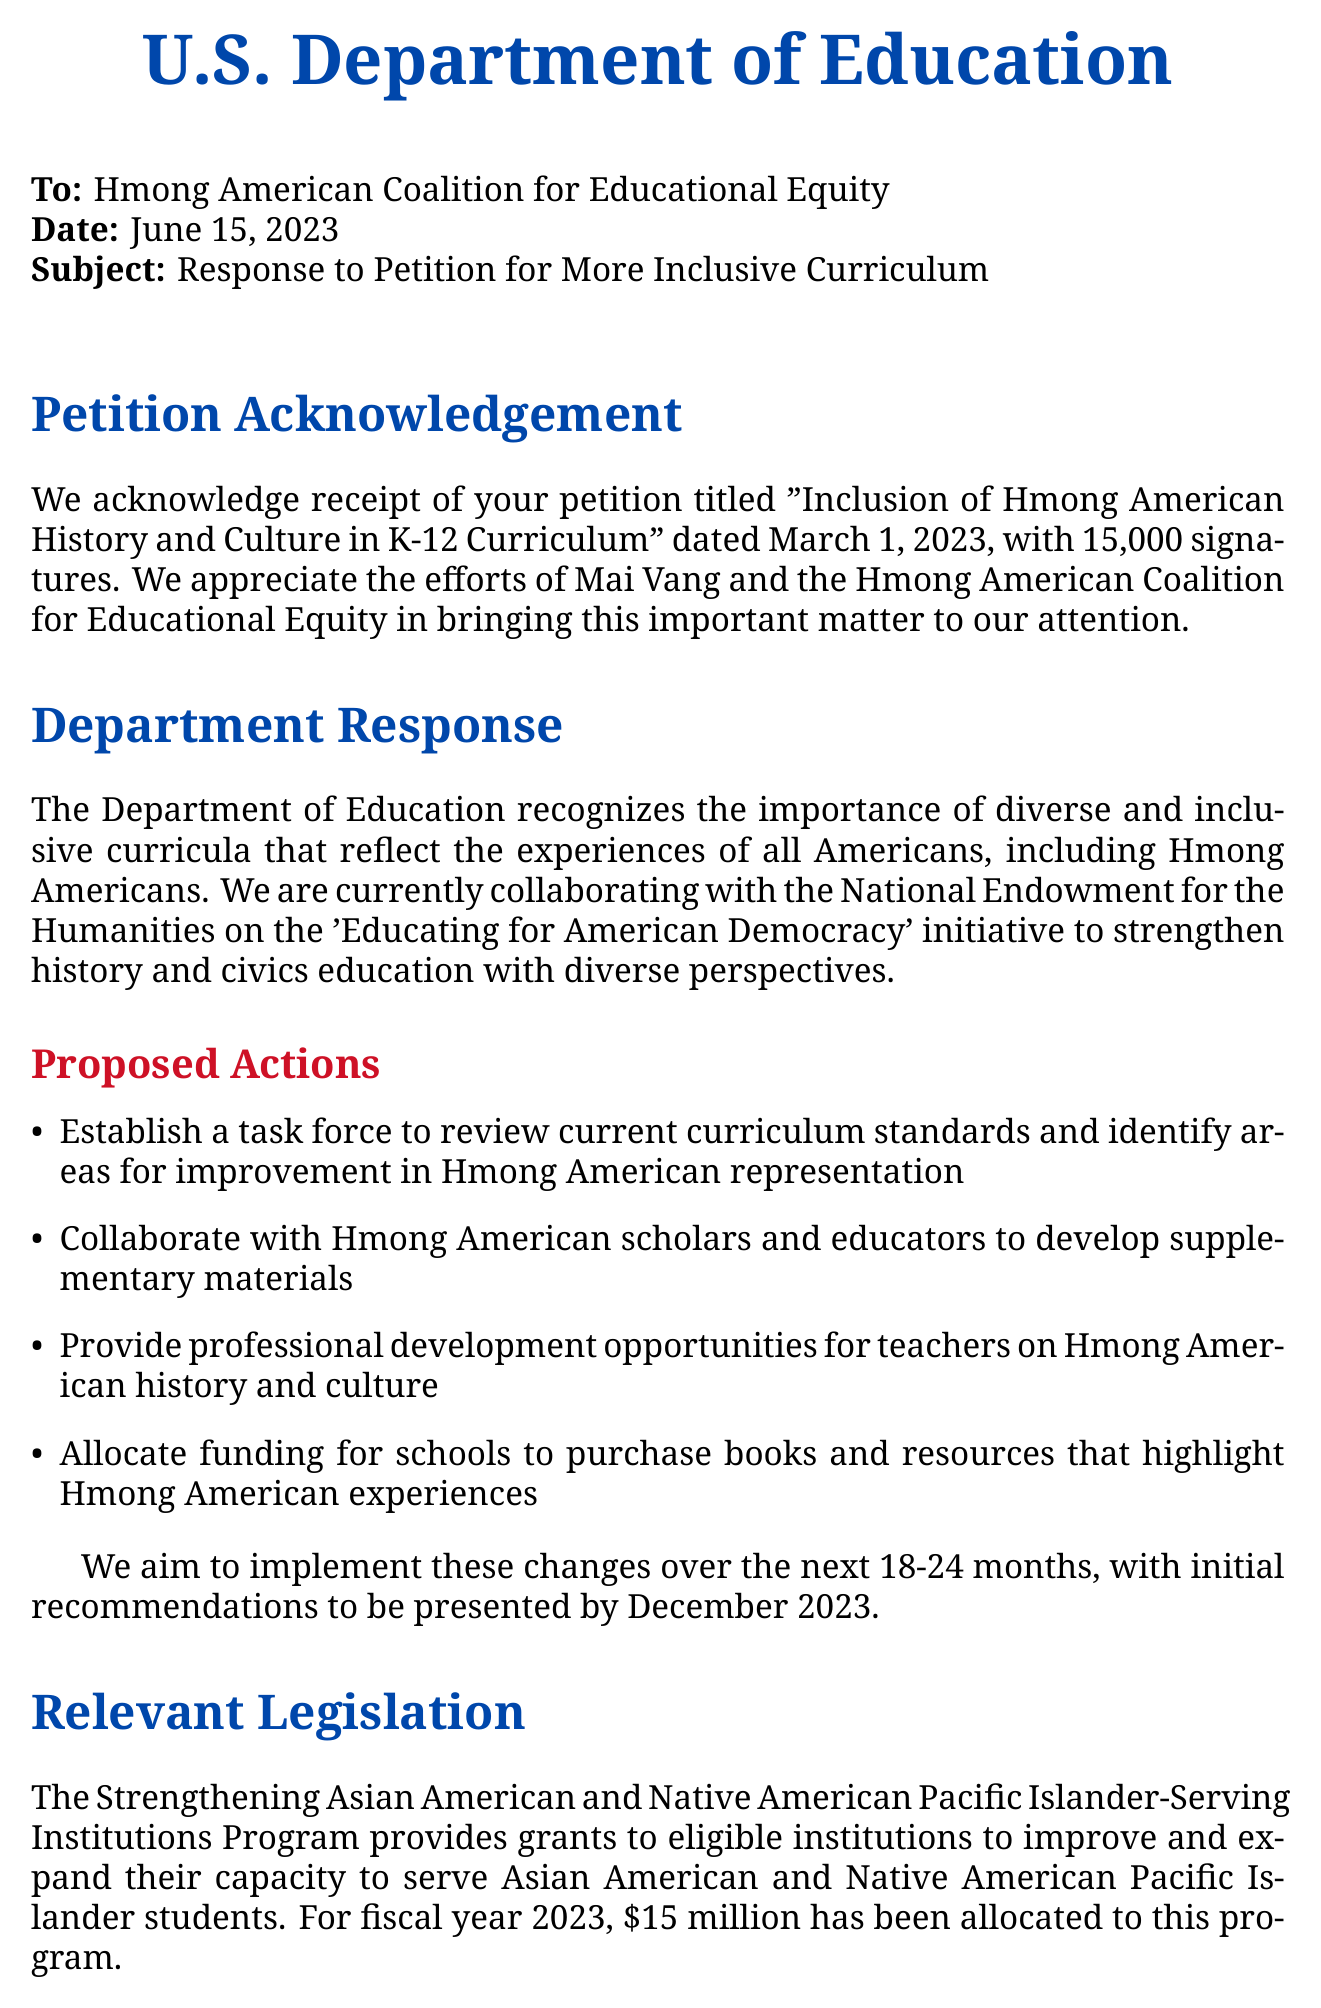What is the title of the petition? The title of the petition is stated in the document as "Inclusion of Hmong American History and Culture in K-12 Curriculum."
Answer: Inclusion of Hmong American History and Culture in K-12 Curriculum Who was the primary petitioner? The primary petitioner is identified in the document as Mai Vang, representing the Hmong American Coalition for Educational Equity.
Answer: Mai Vang How many signatures were collected? The number of signatures is provided as 15,000 in the document.
Answer: 15,000 What initiative is the Department of Education working with? The department is collaborating on the "Educating for American Democracy" initiative, as mentioned in the response.
Answer: Educating for American Democracy What is one proposed action for improving Hmong American representation? One proposed action listed is to "Establish a task force to review current curriculum standards and identify areas for improvement in Hmong American representation."
Answer: Establish a task force What is the allocated funding for the relevant legislation? The document states that $15 million has been allocated for fiscal year 2023 for the relevant legislation.
Answer: $15 million When is the Hmong American Curriculum Development Workshop scheduled? The document provides the date for this workshop, which is August 10-12, 2023.
Answer: August 10-12, 2023 Who is the contact person listed in the document? The contact person is identified as Dr. Lisa Wong, who is the Director of the Office of Educational Equity.
Answer: Dr. Lisa Wong What is the date of the stakeholder meeting? The document specifies that the stakeholder meeting is set for July 20, 2023.
Answer: July 20, 2023 